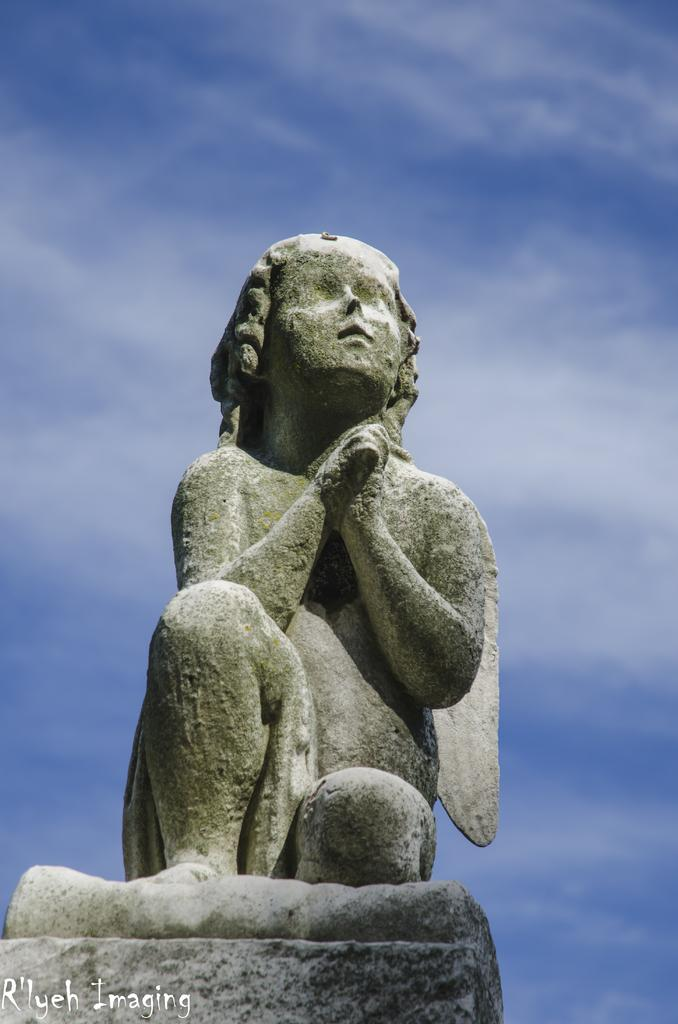What is the main subject of the image? There is a sculpture in the image. What type of juice is being distributed by the kite in the image? There is no juice or kite present in the image; it only features a sculpture. 